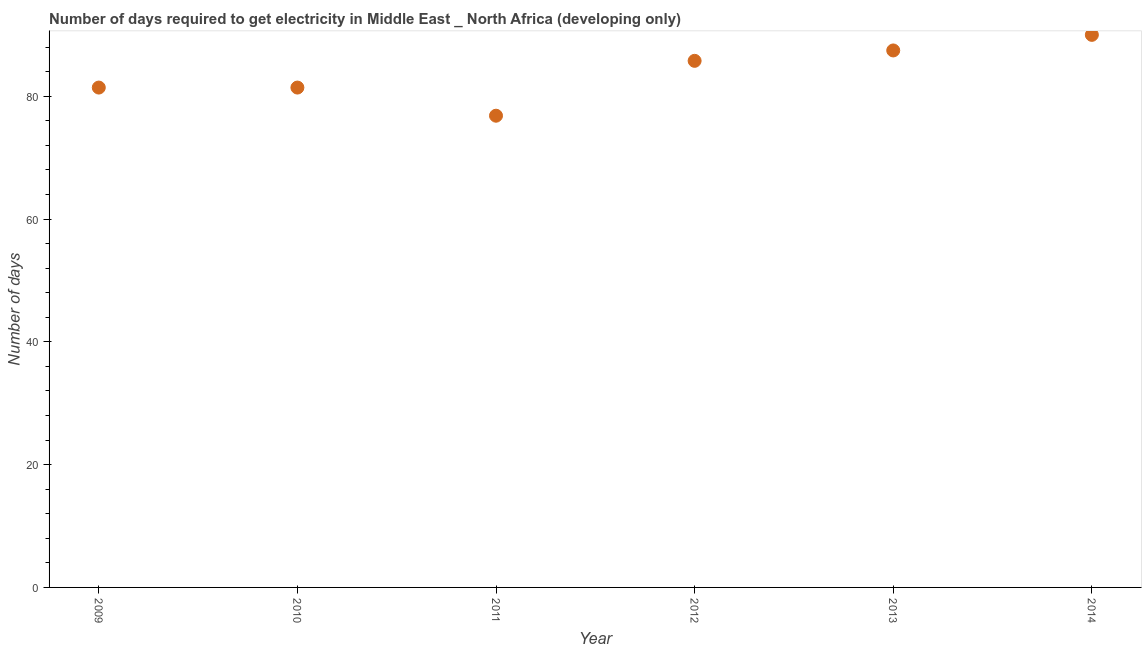What is the time to get electricity in 2012?
Your answer should be compact. 85.77. Across all years, what is the minimum time to get electricity?
Make the answer very short. 76.83. In which year was the time to get electricity maximum?
Make the answer very short. 2014. What is the sum of the time to get electricity?
Keep it short and to the point. 502.9. What is the difference between the time to get electricity in 2010 and 2012?
Make the answer very short. -4.35. What is the average time to get electricity per year?
Your answer should be very brief. 83.82. What is the median time to get electricity?
Your answer should be compact. 83.59. Do a majority of the years between 2012 and 2014 (inclusive) have time to get electricity greater than 80 ?
Give a very brief answer. Yes. What is the ratio of the time to get electricity in 2010 to that in 2013?
Make the answer very short. 0.93. What is the difference between the highest and the second highest time to get electricity?
Your answer should be compact. 2.54. Is the sum of the time to get electricity in 2013 and 2014 greater than the maximum time to get electricity across all years?
Offer a terse response. Yes. What is the difference between the highest and the lowest time to get electricity?
Provide a succinct answer. 13.17. In how many years, is the time to get electricity greater than the average time to get electricity taken over all years?
Your answer should be very brief. 3. Does the time to get electricity monotonically increase over the years?
Your answer should be compact. No. How many dotlines are there?
Your response must be concise. 1. Are the values on the major ticks of Y-axis written in scientific E-notation?
Ensure brevity in your answer.  No. Does the graph contain any zero values?
Provide a succinct answer. No. What is the title of the graph?
Your answer should be very brief. Number of days required to get electricity in Middle East _ North Africa (developing only). What is the label or title of the X-axis?
Your response must be concise. Year. What is the label or title of the Y-axis?
Your answer should be compact. Number of days. What is the Number of days in 2009?
Ensure brevity in your answer.  81.42. What is the Number of days in 2010?
Offer a very short reply. 81.42. What is the Number of days in 2011?
Ensure brevity in your answer.  76.83. What is the Number of days in 2012?
Your answer should be very brief. 85.77. What is the Number of days in 2013?
Your response must be concise. 87.46. What is the Number of days in 2014?
Provide a succinct answer. 90. What is the difference between the Number of days in 2009 and 2010?
Ensure brevity in your answer.  0. What is the difference between the Number of days in 2009 and 2011?
Offer a terse response. 4.58. What is the difference between the Number of days in 2009 and 2012?
Your response must be concise. -4.35. What is the difference between the Number of days in 2009 and 2013?
Offer a very short reply. -6.04. What is the difference between the Number of days in 2009 and 2014?
Offer a very short reply. -8.58. What is the difference between the Number of days in 2010 and 2011?
Provide a short and direct response. 4.58. What is the difference between the Number of days in 2010 and 2012?
Ensure brevity in your answer.  -4.35. What is the difference between the Number of days in 2010 and 2013?
Make the answer very short. -6.04. What is the difference between the Number of days in 2010 and 2014?
Provide a short and direct response. -8.58. What is the difference between the Number of days in 2011 and 2012?
Your answer should be compact. -8.94. What is the difference between the Number of days in 2011 and 2013?
Provide a short and direct response. -10.63. What is the difference between the Number of days in 2011 and 2014?
Your answer should be compact. -13.17. What is the difference between the Number of days in 2012 and 2013?
Offer a very short reply. -1.69. What is the difference between the Number of days in 2012 and 2014?
Make the answer very short. -4.23. What is the difference between the Number of days in 2013 and 2014?
Provide a short and direct response. -2.54. What is the ratio of the Number of days in 2009 to that in 2011?
Your answer should be compact. 1.06. What is the ratio of the Number of days in 2009 to that in 2012?
Provide a short and direct response. 0.95. What is the ratio of the Number of days in 2009 to that in 2014?
Make the answer very short. 0.91. What is the ratio of the Number of days in 2010 to that in 2011?
Your answer should be compact. 1.06. What is the ratio of the Number of days in 2010 to that in 2012?
Your answer should be compact. 0.95. What is the ratio of the Number of days in 2010 to that in 2013?
Give a very brief answer. 0.93. What is the ratio of the Number of days in 2010 to that in 2014?
Offer a very short reply. 0.91. What is the ratio of the Number of days in 2011 to that in 2012?
Offer a terse response. 0.9. What is the ratio of the Number of days in 2011 to that in 2013?
Keep it short and to the point. 0.88. What is the ratio of the Number of days in 2011 to that in 2014?
Give a very brief answer. 0.85. What is the ratio of the Number of days in 2012 to that in 2014?
Offer a terse response. 0.95. 